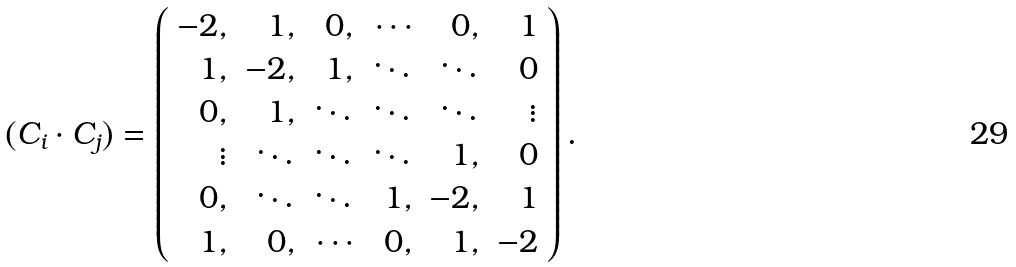Convert formula to latex. <formula><loc_0><loc_0><loc_500><loc_500>( C _ { i } \cdot C _ { j } ) = \left ( \begin{array} { r r r r r r } { - 2 , } & { 1 , } & { 0 , } & { \cdots } & { 0 , } & { 1 } \\ { 1 , } & { - 2 , } & { 1 , } & { \ddots } & { \ddots } & { 0 } \\ { 0 , } & { 1 , } & { \ddots } & { \ddots } & { \ddots } & { \vdots } \\ { \vdots } & { \ddots } & { \ddots } & { \ddots } & { 1 , } & { 0 } \\ { 0 , } & { \ddots } & { \ddots } & { 1 , } & { - 2 , } & { 1 } \\ { 1 , } & { 0 , } & { \cdots } & { 0 , } & { 1 , } & { - 2 } \end{array} \right ) .</formula> 